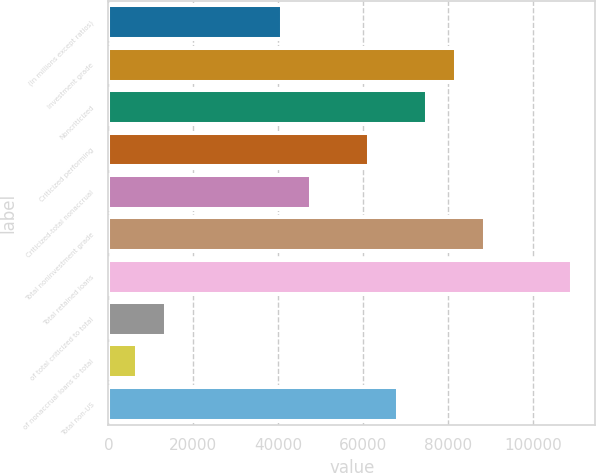Convert chart to OTSL. <chart><loc_0><loc_0><loc_500><loc_500><bar_chart><fcel>(in millions except ratios)<fcel>Investment grade<fcel>Noncriticized<fcel>Criticized performing<fcel>Criticized-total nonaccrual<fcel>Total noninvestment grade<fcel>Total retained loans<fcel>of total criticized to total<fcel>of nonaccrual loans to total<fcel>Total non-US<nl><fcel>40945.3<fcel>81888.9<fcel>75064.9<fcel>61417.1<fcel>47769.3<fcel>88712.8<fcel>109185<fcel>13649.7<fcel>6825.74<fcel>68241<nl></chart> 